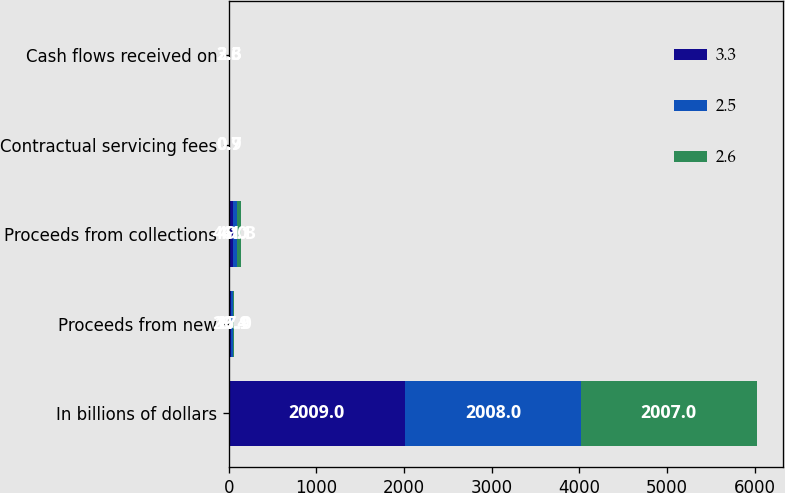<chart> <loc_0><loc_0><loc_500><loc_500><stacked_bar_chart><ecel><fcel>In billions of dollars<fcel>Proceeds from new<fcel>Proceeds from collections<fcel>Contractual servicing fees<fcel>Cash flows received on<nl><fcel>3.3<fcel>2009<fcel>29.4<fcel>46<fcel>0.7<fcel>2.6<nl><fcel>2.5<fcel>2008<fcel>16.9<fcel>49.1<fcel>0.7<fcel>3.3<nl><fcel>2.6<fcel>2007<fcel>17<fcel>41.3<fcel>0.9<fcel>2.5<nl></chart> 